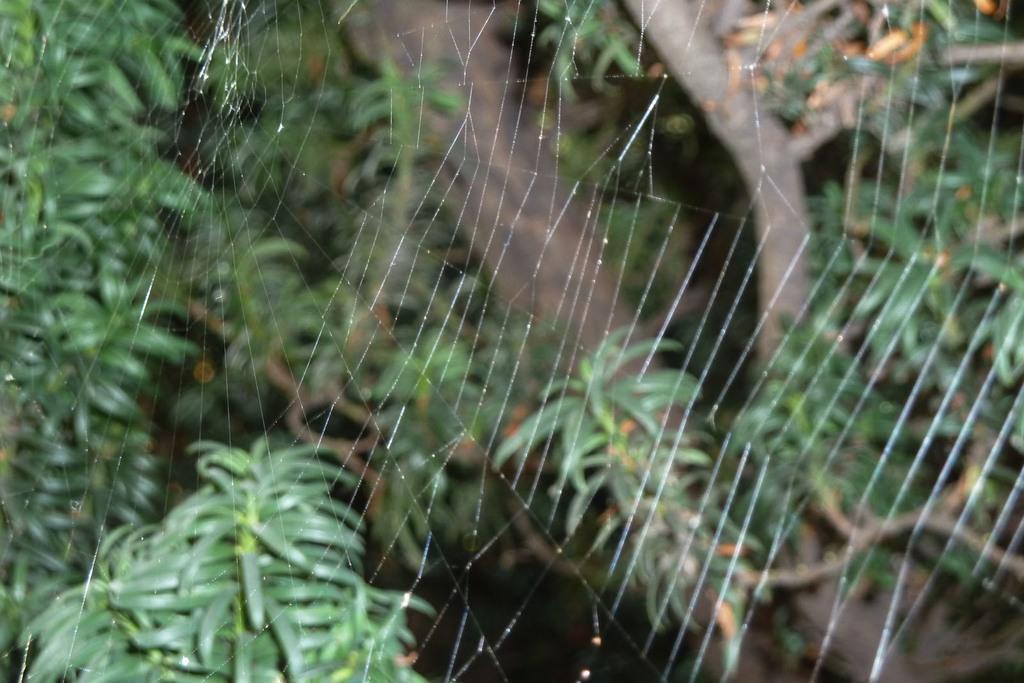How would you summarize this image in a sentence or two? In this image I can see the spider web in the front. In the background I can see a branch and leaves of a tree. I can also see this image is little bit blurry in the background. 